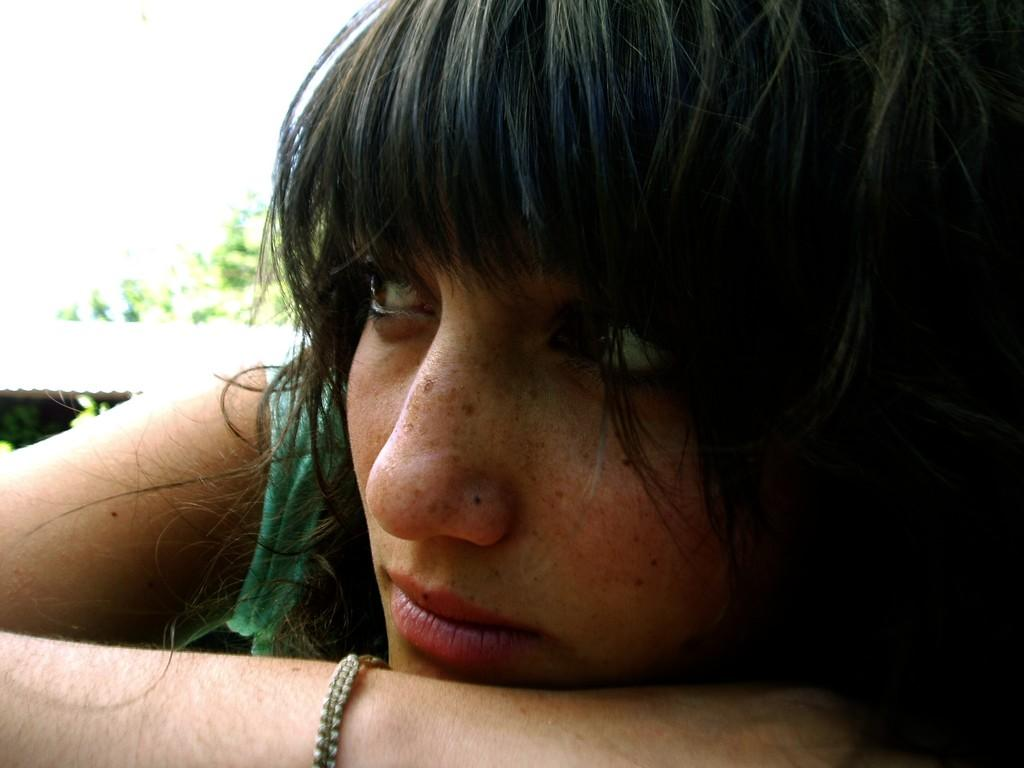Who is the main subject in the image? There is a woman in the image. What part of the woman's face can be seen in the image? The woman's face is visible in the foreground. What color is the dress the woman is wearing? The woman is wearing a green dress. What structures or objects can be seen in the background of the image? There is a shed and trees in the background of the image. Can you tell me how deep the river is in the image? There is no river present in the image; it features a woman in the foreground and a shed and trees in the background. 